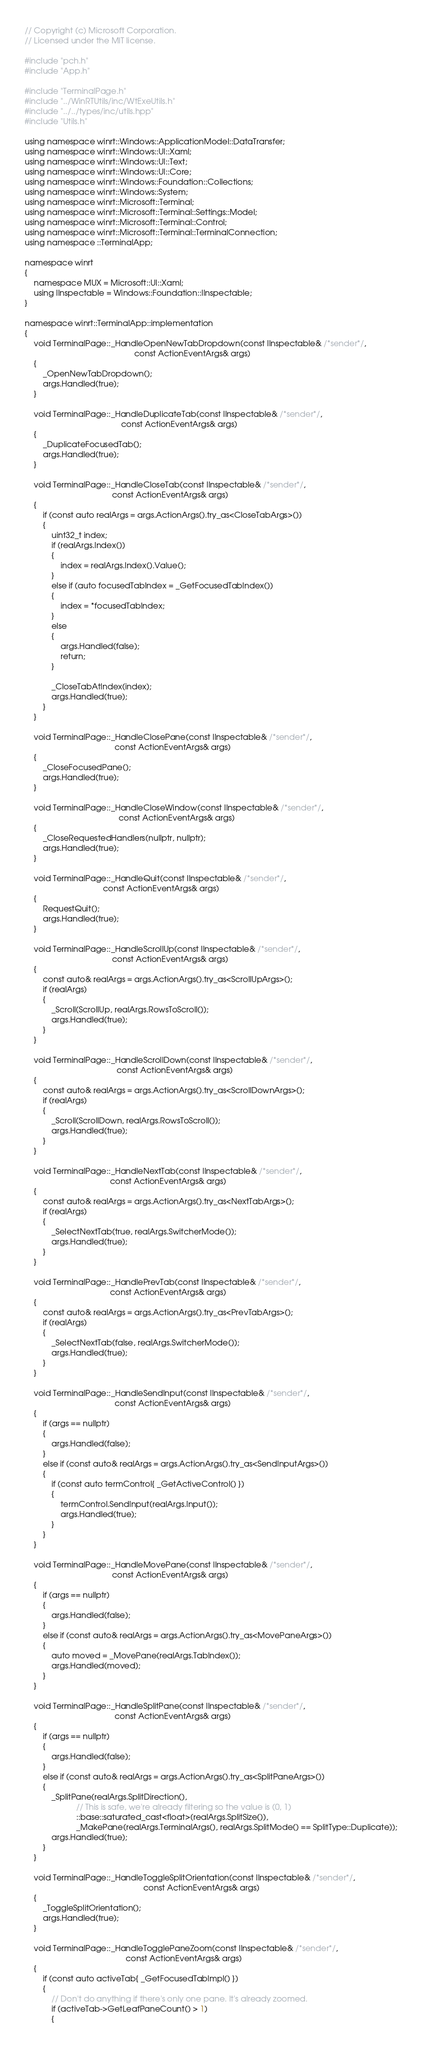Convert code to text. <code><loc_0><loc_0><loc_500><loc_500><_C++_>// Copyright (c) Microsoft Corporation.
// Licensed under the MIT license.

#include "pch.h"
#include "App.h"

#include "TerminalPage.h"
#include "../WinRTUtils/inc/WtExeUtils.h"
#include "../../types/inc/utils.hpp"
#include "Utils.h"

using namespace winrt::Windows::ApplicationModel::DataTransfer;
using namespace winrt::Windows::UI::Xaml;
using namespace winrt::Windows::UI::Text;
using namespace winrt::Windows::UI::Core;
using namespace winrt::Windows::Foundation::Collections;
using namespace winrt::Windows::System;
using namespace winrt::Microsoft::Terminal;
using namespace winrt::Microsoft::Terminal::Settings::Model;
using namespace winrt::Microsoft::Terminal::Control;
using namespace winrt::Microsoft::Terminal::TerminalConnection;
using namespace ::TerminalApp;

namespace winrt
{
    namespace MUX = Microsoft::UI::Xaml;
    using IInspectable = Windows::Foundation::IInspectable;
}

namespace winrt::TerminalApp::implementation
{
    void TerminalPage::_HandleOpenNewTabDropdown(const IInspectable& /*sender*/,
                                                 const ActionEventArgs& args)
    {
        _OpenNewTabDropdown();
        args.Handled(true);
    }

    void TerminalPage::_HandleDuplicateTab(const IInspectable& /*sender*/,
                                           const ActionEventArgs& args)
    {
        _DuplicateFocusedTab();
        args.Handled(true);
    }

    void TerminalPage::_HandleCloseTab(const IInspectable& /*sender*/,
                                       const ActionEventArgs& args)
    {
        if (const auto realArgs = args.ActionArgs().try_as<CloseTabArgs>())
        {
            uint32_t index;
            if (realArgs.Index())
            {
                index = realArgs.Index().Value();
            }
            else if (auto focusedTabIndex = _GetFocusedTabIndex())
            {
                index = *focusedTabIndex;
            }
            else
            {
                args.Handled(false);
                return;
            }

            _CloseTabAtIndex(index);
            args.Handled(true);
        }
    }

    void TerminalPage::_HandleClosePane(const IInspectable& /*sender*/,
                                        const ActionEventArgs& args)
    {
        _CloseFocusedPane();
        args.Handled(true);
    }

    void TerminalPage::_HandleCloseWindow(const IInspectable& /*sender*/,
                                          const ActionEventArgs& args)
    {
        _CloseRequestedHandlers(nullptr, nullptr);
        args.Handled(true);
    }

    void TerminalPage::_HandleQuit(const IInspectable& /*sender*/,
                                   const ActionEventArgs& args)
    {
        RequestQuit();
        args.Handled(true);
    }

    void TerminalPage::_HandleScrollUp(const IInspectable& /*sender*/,
                                       const ActionEventArgs& args)
    {
        const auto& realArgs = args.ActionArgs().try_as<ScrollUpArgs>();
        if (realArgs)
        {
            _Scroll(ScrollUp, realArgs.RowsToScroll());
            args.Handled(true);
        }
    }

    void TerminalPage::_HandleScrollDown(const IInspectable& /*sender*/,
                                         const ActionEventArgs& args)
    {
        const auto& realArgs = args.ActionArgs().try_as<ScrollDownArgs>();
        if (realArgs)
        {
            _Scroll(ScrollDown, realArgs.RowsToScroll());
            args.Handled(true);
        }
    }

    void TerminalPage::_HandleNextTab(const IInspectable& /*sender*/,
                                      const ActionEventArgs& args)
    {
        const auto& realArgs = args.ActionArgs().try_as<NextTabArgs>();
        if (realArgs)
        {
            _SelectNextTab(true, realArgs.SwitcherMode());
            args.Handled(true);
        }
    }

    void TerminalPage::_HandlePrevTab(const IInspectable& /*sender*/,
                                      const ActionEventArgs& args)
    {
        const auto& realArgs = args.ActionArgs().try_as<PrevTabArgs>();
        if (realArgs)
        {
            _SelectNextTab(false, realArgs.SwitcherMode());
            args.Handled(true);
        }
    }

    void TerminalPage::_HandleSendInput(const IInspectable& /*sender*/,
                                        const ActionEventArgs& args)
    {
        if (args == nullptr)
        {
            args.Handled(false);
        }
        else if (const auto& realArgs = args.ActionArgs().try_as<SendInputArgs>())
        {
            if (const auto termControl{ _GetActiveControl() })
            {
                termControl.SendInput(realArgs.Input());
                args.Handled(true);
            }
        }
    }

    void TerminalPage::_HandleMovePane(const IInspectable& /*sender*/,
                                       const ActionEventArgs& args)
    {
        if (args == nullptr)
        {
            args.Handled(false);
        }
        else if (const auto& realArgs = args.ActionArgs().try_as<MovePaneArgs>())
        {
            auto moved = _MovePane(realArgs.TabIndex());
            args.Handled(moved);
        }
    }

    void TerminalPage::_HandleSplitPane(const IInspectable& /*sender*/,
                                        const ActionEventArgs& args)
    {
        if (args == nullptr)
        {
            args.Handled(false);
        }
        else if (const auto& realArgs = args.ActionArgs().try_as<SplitPaneArgs>())
        {
            _SplitPane(realArgs.SplitDirection(),
                       // This is safe, we're already filtering so the value is (0, 1)
                       ::base::saturated_cast<float>(realArgs.SplitSize()),
                       _MakePane(realArgs.TerminalArgs(), realArgs.SplitMode() == SplitType::Duplicate));
            args.Handled(true);
        }
    }

    void TerminalPage::_HandleToggleSplitOrientation(const IInspectable& /*sender*/,
                                                     const ActionEventArgs& args)
    {
        _ToggleSplitOrientation();
        args.Handled(true);
    }

    void TerminalPage::_HandleTogglePaneZoom(const IInspectable& /*sender*/,
                                             const ActionEventArgs& args)
    {
        if (const auto activeTab{ _GetFocusedTabImpl() })
        {
            // Don't do anything if there's only one pane. It's already zoomed.
            if (activeTab->GetLeafPaneCount() > 1)
            {</code> 